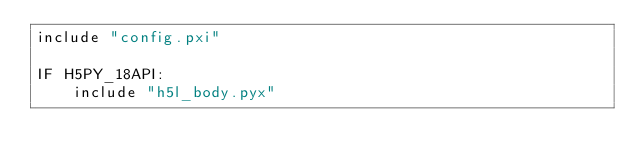Convert code to text. <code><loc_0><loc_0><loc_500><loc_500><_Cython_>include "config.pxi"

IF H5PY_18API:
    include "h5l_body.pyx"
</code> 